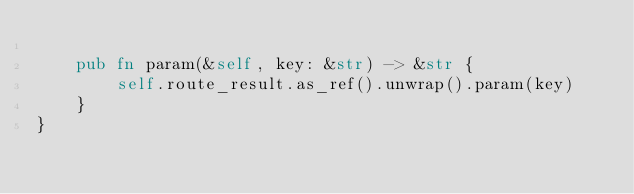<code> <loc_0><loc_0><loc_500><loc_500><_Rust_>
    pub fn param(&self, key: &str) -> &str {
        self.route_result.as_ref().unwrap().param(key)
    }
}
</code> 